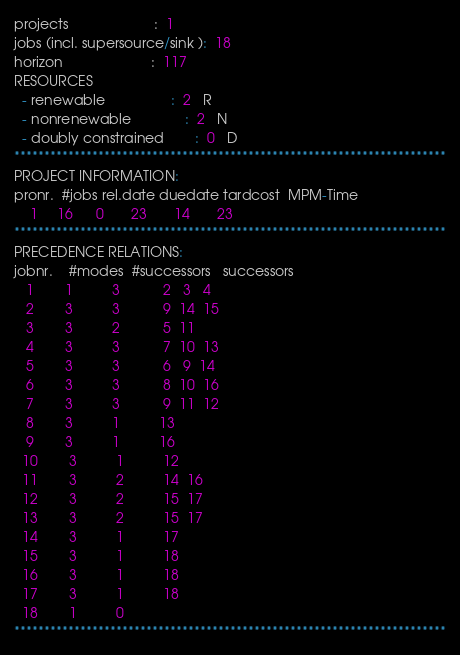Convert code to text. <code><loc_0><loc_0><loc_500><loc_500><_ObjectiveC_>projects                      :  1
jobs (incl. supersource/sink ):  18
horizon                       :  117
RESOURCES
  - renewable                 :  2   R
  - nonrenewable              :  2   N
  - doubly constrained        :  0   D
************************************************************************
PROJECT INFORMATION:
pronr.  #jobs rel.date duedate tardcost  MPM-Time
    1     16      0       23       14       23
************************************************************************
PRECEDENCE RELATIONS:
jobnr.    #modes  #successors   successors
   1        1          3           2   3   4
   2        3          3           9  14  15
   3        3          2           5  11
   4        3          3           7  10  13
   5        3          3           6   9  14
   6        3          3           8  10  16
   7        3          3           9  11  12
   8        3          1          13
   9        3          1          16
  10        3          1          12
  11        3          2          14  16
  12        3          2          15  17
  13        3          2          15  17
  14        3          1          17
  15        3          1          18
  16        3          1          18
  17        3          1          18
  18        1          0        
************************************************************************</code> 